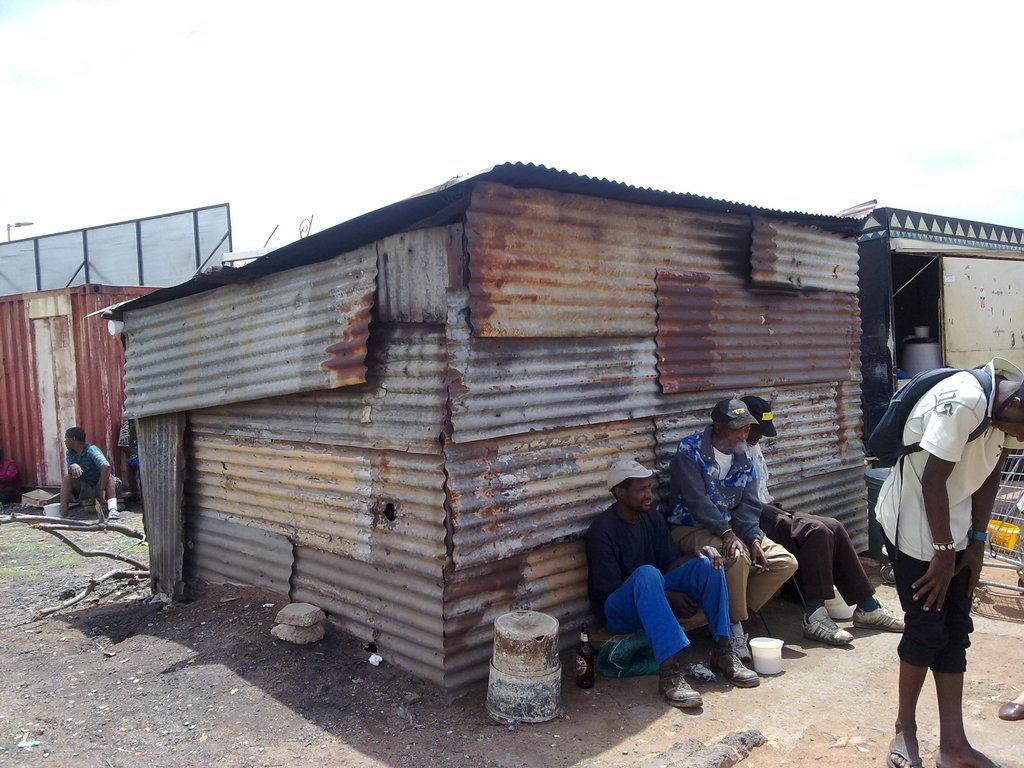Who or what can be seen in the image? There are people in the image. What structures are present in the image? There are sheds in the image. What else can be found in the image besides people and sheds? There are objects in the image. Can you describe the person standing on the right side of the image? A person wearing a backpack is standing on the right side of the image. What can be seen in the background of the image? The sky is visible in the background of the image. What type of bells can be heard ringing in the image? There are no bells present in the image, and therefore no sound can be heard. Can you describe the wing of the person standing on the right side of the image? There is no person with a wing in the image; the person is wearing a backpack. 